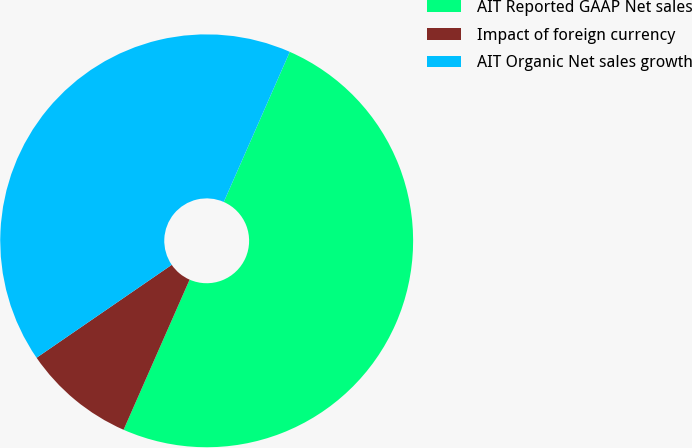Convert chart to OTSL. <chart><loc_0><loc_0><loc_500><loc_500><pie_chart><fcel>AIT Reported GAAP Net sales<fcel>Impact of foreign currency<fcel>AIT Organic Net sales growth<nl><fcel>50.0%<fcel>8.82%<fcel>41.18%<nl></chart> 